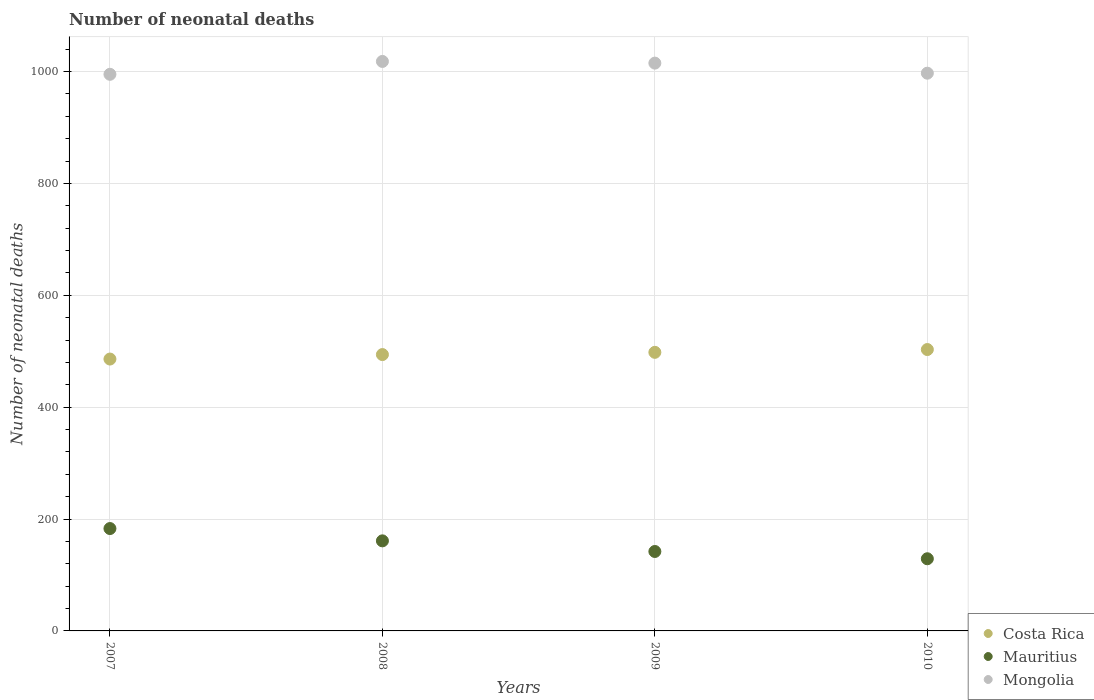Is the number of dotlines equal to the number of legend labels?
Your answer should be very brief. Yes. What is the number of neonatal deaths in in Mauritius in 2010?
Provide a short and direct response. 129. Across all years, what is the maximum number of neonatal deaths in in Mauritius?
Provide a short and direct response. 183. Across all years, what is the minimum number of neonatal deaths in in Costa Rica?
Keep it short and to the point. 486. In which year was the number of neonatal deaths in in Mauritius maximum?
Offer a terse response. 2007. In which year was the number of neonatal deaths in in Costa Rica minimum?
Your response must be concise. 2007. What is the total number of neonatal deaths in in Costa Rica in the graph?
Provide a succinct answer. 1981. What is the difference between the number of neonatal deaths in in Mauritius in 2007 and that in 2008?
Ensure brevity in your answer.  22. What is the difference between the number of neonatal deaths in in Mongolia in 2010 and the number of neonatal deaths in in Mauritius in 2008?
Ensure brevity in your answer.  836. What is the average number of neonatal deaths in in Mongolia per year?
Offer a very short reply. 1006.25. In the year 2009, what is the difference between the number of neonatal deaths in in Costa Rica and number of neonatal deaths in in Mongolia?
Your answer should be compact. -517. What is the ratio of the number of neonatal deaths in in Costa Rica in 2007 to that in 2010?
Make the answer very short. 0.97. Is the number of neonatal deaths in in Costa Rica in 2007 less than that in 2008?
Provide a succinct answer. Yes. What is the difference between the highest and the second highest number of neonatal deaths in in Costa Rica?
Offer a very short reply. 5. What is the difference between the highest and the lowest number of neonatal deaths in in Mauritius?
Offer a very short reply. 54. In how many years, is the number of neonatal deaths in in Costa Rica greater than the average number of neonatal deaths in in Costa Rica taken over all years?
Your answer should be very brief. 2. Is the sum of the number of neonatal deaths in in Mauritius in 2007 and 2008 greater than the maximum number of neonatal deaths in in Costa Rica across all years?
Provide a short and direct response. No. Is the number of neonatal deaths in in Costa Rica strictly greater than the number of neonatal deaths in in Mongolia over the years?
Keep it short and to the point. No. Is the number of neonatal deaths in in Costa Rica strictly less than the number of neonatal deaths in in Mongolia over the years?
Offer a very short reply. Yes. How many dotlines are there?
Provide a short and direct response. 3. How many years are there in the graph?
Your response must be concise. 4. What is the difference between two consecutive major ticks on the Y-axis?
Your answer should be very brief. 200. Are the values on the major ticks of Y-axis written in scientific E-notation?
Provide a short and direct response. No. Does the graph contain any zero values?
Ensure brevity in your answer.  No. Where does the legend appear in the graph?
Your answer should be compact. Bottom right. How many legend labels are there?
Make the answer very short. 3. How are the legend labels stacked?
Ensure brevity in your answer.  Vertical. What is the title of the graph?
Ensure brevity in your answer.  Number of neonatal deaths. What is the label or title of the X-axis?
Offer a very short reply. Years. What is the label or title of the Y-axis?
Your response must be concise. Number of neonatal deaths. What is the Number of neonatal deaths in Costa Rica in 2007?
Offer a terse response. 486. What is the Number of neonatal deaths of Mauritius in 2007?
Offer a very short reply. 183. What is the Number of neonatal deaths in Mongolia in 2007?
Offer a terse response. 995. What is the Number of neonatal deaths of Costa Rica in 2008?
Your answer should be compact. 494. What is the Number of neonatal deaths in Mauritius in 2008?
Make the answer very short. 161. What is the Number of neonatal deaths of Mongolia in 2008?
Offer a terse response. 1018. What is the Number of neonatal deaths in Costa Rica in 2009?
Ensure brevity in your answer.  498. What is the Number of neonatal deaths in Mauritius in 2009?
Your answer should be compact. 142. What is the Number of neonatal deaths in Mongolia in 2009?
Your answer should be compact. 1015. What is the Number of neonatal deaths in Costa Rica in 2010?
Give a very brief answer. 503. What is the Number of neonatal deaths in Mauritius in 2010?
Provide a short and direct response. 129. What is the Number of neonatal deaths of Mongolia in 2010?
Ensure brevity in your answer.  997. Across all years, what is the maximum Number of neonatal deaths in Costa Rica?
Make the answer very short. 503. Across all years, what is the maximum Number of neonatal deaths in Mauritius?
Ensure brevity in your answer.  183. Across all years, what is the maximum Number of neonatal deaths of Mongolia?
Ensure brevity in your answer.  1018. Across all years, what is the minimum Number of neonatal deaths in Costa Rica?
Offer a very short reply. 486. Across all years, what is the minimum Number of neonatal deaths of Mauritius?
Provide a succinct answer. 129. Across all years, what is the minimum Number of neonatal deaths in Mongolia?
Your response must be concise. 995. What is the total Number of neonatal deaths of Costa Rica in the graph?
Provide a succinct answer. 1981. What is the total Number of neonatal deaths in Mauritius in the graph?
Offer a very short reply. 615. What is the total Number of neonatal deaths of Mongolia in the graph?
Offer a very short reply. 4025. What is the difference between the Number of neonatal deaths of Costa Rica in 2007 and that in 2008?
Provide a short and direct response. -8. What is the difference between the Number of neonatal deaths of Mongolia in 2007 and that in 2008?
Offer a terse response. -23. What is the difference between the Number of neonatal deaths of Costa Rica in 2007 and that in 2009?
Ensure brevity in your answer.  -12. What is the difference between the Number of neonatal deaths of Mauritius in 2007 and that in 2009?
Your response must be concise. 41. What is the difference between the Number of neonatal deaths in Costa Rica in 2007 and that in 2010?
Offer a very short reply. -17. What is the difference between the Number of neonatal deaths of Mongolia in 2007 and that in 2010?
Provide a succinct answer. -2. What is the difference between the Number of neonatal deaths of Costa Rica in 2008 and that in 2009?
Ensure brevity in your answer.  -4. What is the difference between the Number of neonatal deaths in Mongolia in 2008 and that in 2009?
Provide a succinct answer. 3. What is the difference between the Number of neonatal deaths of Costa Rica in 2009 and that in 2010?
Keep it short and to the point. -5. What is the difference between the Number of neonatal deaths of Mauritius in 2009 and that in 2010?
Ensure brevity in your answer.  13. What is the difference between the Number of neonatal deaths of Mongolia in 2009 and that in 2010?
Your response must be concise. 18. What is the difference between the Number of neonatal deaths of Costa Rica in 2007 and the Number of neonatal deaths of Mauritius in 2008?
Your answer should be compact. 325. What is the difference between the Number of neonatal deaths in Costa Rica in 2007 and the Number of neonatal deaths in Mongolia in 2008?
Keep it short and to the point. -532. What is the difference between the Number of neonatal deaths of Mauritius in 2007 and the Number of neonatal deaths of Mongolia in 2008?
Provide a short and direct response. -835. What is the difference between the Number of neonatal deaths of Costa Rica in 2007 and the Number of neonatal deaths of Mauritius in 2009?
Give a very brief answer. 344. What is the difference between the Number of neonatal deaths in Costa Rica in 2007 and the Number of neonatal deaths in Mongolia in 2009?
Provide a succinct answer. -529. What is the difference between the Number of neonatal deaths in Mauritius in 2007 and the Number of neonatal deaths in Mongolia in 2009?
Offer a very short reply. -832. What is the difference between the Number of neonatal deaths in Costa Rica in 2007 and the Number of neonatal deaths in Mauritius in 2010?
Provide a short and direct response. 357. What is the difference between the Number of neonatal deaths in Costa Rica in 2007 and the Number of neonatal deaths in Mongolia in 2010?
Make the answer very short. -511. What is the difference between the Number of neonatal deaths of Mauritius in 2007 and the Number of neonatal deaths of Mongolia in 2010?
Your response must be concise. -814. What is the difference between the Number of neonatal deaths in Costa Rica in 2008 and the Number of neonatal deaths in Mauritius in 2009?
Ensure brevity in your answer.  352. What is the difference between the Number of neonatal deaths of Costa Rica in 2008 and the Number of neonatal deaths of Mongolia in 2009?
Your answer should be very brief. -521. What is the difference between the Number of neonatal deaths in Mauritius in 2008 and the Number of neonatal deaths in Mongolia in 2009?
Your response must be concise. -854. What is the difference between the Number of neonatal deaths of Costa Rica in 2008 and the Number of neonatal deaths of Mauritius in 2010?
Offer a very short reply. 365. What is the difference between the Number of neonatal deaths of Costa Rica in 2008 and the Number of neonatal deaths of Mongolia in 2010?
Give a very brief answer. -503. What is the difference between the Number of neonatal deaths of Mauritius in 2008 and the Number of neonatal deaths of Mongolia in 2010?
Your answer should be very brief. -836. What is the difference between the Number of neonatal deaths of Costa Rica in 2009 and the Number of neonatal deaths of Mauritius in 2010?
Your answer should be very brief. 369. What is the difference between the Number of neonatal deaths of Costa Rica in 2009 and the Number of neonatal deaths of Mongolia in 2010?
Your answer should be compact. -499. What is the difference between the Number of neonatal deaths of Mauritius in 2009 and the Number of neonatal deaths of Mongolia in 2010?
Offer a terse response. -855. What is the average Number of neonatal deaths of Costa Rica per year?
Provide a succinct answer. 495.25. What is the average Number of neonatal deaths in Mauritius per year?
Offer a very short reply. 153.75. What is the average Number of neonatal deaths in Mongolia per year?
Offer a terse response. 1006.25. In the year 2007, what is the difference between the Number of neonatal deaths of Costa Rica and Number of neonatal deaths of Mauritius?
Offer a terse response. 303. In the year 2007, what is the difference between the Number of neonatal deaths in Costa Rica and Number of neonatal deaths in Mongolia?
Keep it short and to the point. -509. In the year 2007, what is the difference between the Number of neonatal deaths of Mauritius and Number of neonatal deaths of Mongolia?
Keep it short and to the point. -812. In the year 2008, what is the difference between the Number of neonatal deaths in Costa Rica and Number of neonatal deaths in Mauritius?
Provide a short and direct response. 333. In the year 2008, what is the difference between the Number of neonatal deaths of Costa Rica and Number of neonatal deaths of Mongolia?
Make the answer very short. -524. In the year 2008, what is the difference between the Number of neonatal deaths of Mauritius and Number of neonatal deaths of Mongolia?
Your answer should be very brief. -857. In the year 2009, what is the difference between the Number of neonatal deaths of Costa Rica and Number of neonatal deaths of Mauritius?
Your answer should be compact. 356. In the year 2009, what is the difference between the Number of neonatal deaths in Costa Rica and Number of neonatal deaths in Mongolia?
Keep it short and to the point. -517. In the year 2009, what is the difference between the Number of neonatal deaths of Mauritius and Number of neonatal deaths of Mongolia?
Offer a terse response. -873. In the year 2010, what is the difference between the Number of neonatal deaths in Costa Rica and Number of neonatal deaths in Mauritius?
Provide a succinct answer. 374. In the year 2010, what is the difference between the Number of neonatal deaths of Costa Rica and Number of neonatal deaths of Mongolia?
Keep it short and to the point. -494. In the year 2010, what is the difference between the Number of neonatal deaths in Mauritius and Number of neonatal deaths in Mongolia?
Offer a very short reply. -868. What is the ratio of the Number of neonatal deaths in Costa Rica in 2007 to that in 2008?
Offer a very short reply. 0.98. What is the ratio of the Number of neonatal deaths in Mauritius in 2007 to that in 2008?
Make the answer very short. 1.14. What is the ratio of the Number of neonatal deaths of Mongolia in 2007 to that in 2008?
Give a very brief answer. 0.98. What is the ratio of the Number of neonatal deaths of Costa Rica in 2007 to that in 2009?
Your response must be concise. 0.98. What is the ratio of the Number of neonatal deaths of Mauritius in 2007 to that in 2009?
Your answer should be very brief. 1.29. What is the ratio of the Number of neonatal deaths in Mongolia in 2007 to that in 2009?
Provide a short and direct response. 0.98. What is the ratio of the Number of neonatal deaths of Costa Rica in 2007 to that in 2010?
Give a very brief answer. 0.97. What is the ratio of the Number of neonatal deaths in Mauritius in 2007 to that in 2010?
Your answer should be very brief. 1.42. What is the ratio of the Number of neonatal deaths of Mongolia in 2007 to that in 2010?
Provide a succinct answer. 1. What is the ratio of the Number of neonatal deaths of Mauritius in 2008 to that in 2009?
Make the answer very short. 1.13. What is the ratio of the Number of neonatal deaths of Mongolia in 2008 to that in 2009?
Ensure brevity in your answer.  1. What is the ratio of the Number of neonatal deaths of Costa Rica in 2008 to that in 2010?
Your response must be concise. 0.98. What is the ratio of the Number of neonatal deaths in Mauritius in 2008 to that in 2010?
Provide a short and direct response. 1.25. What is the ratio of the Number of neonatal deaths of Mongolia in 2008 to that in 2010?
Give a very brief answer. 1.02. What is the ratio of the Number of neonatal deaths in Mauritius in 2009 to that in 2010?
Your answer should be very brief. 1.1. What is the ratio of the Number of neonatal deaths in Mongolia in 2009 to that in 2010?
Your answer should be compact. 1.02. What is the difference between the highest and the second highest Number of neonatal deaths in Mongolia?
Provide a short and direct response. 3. What is the difference between the highest and the lowest Number of neonatal deaths of Mongolia?
Ensure brevity in your answer.  23. 